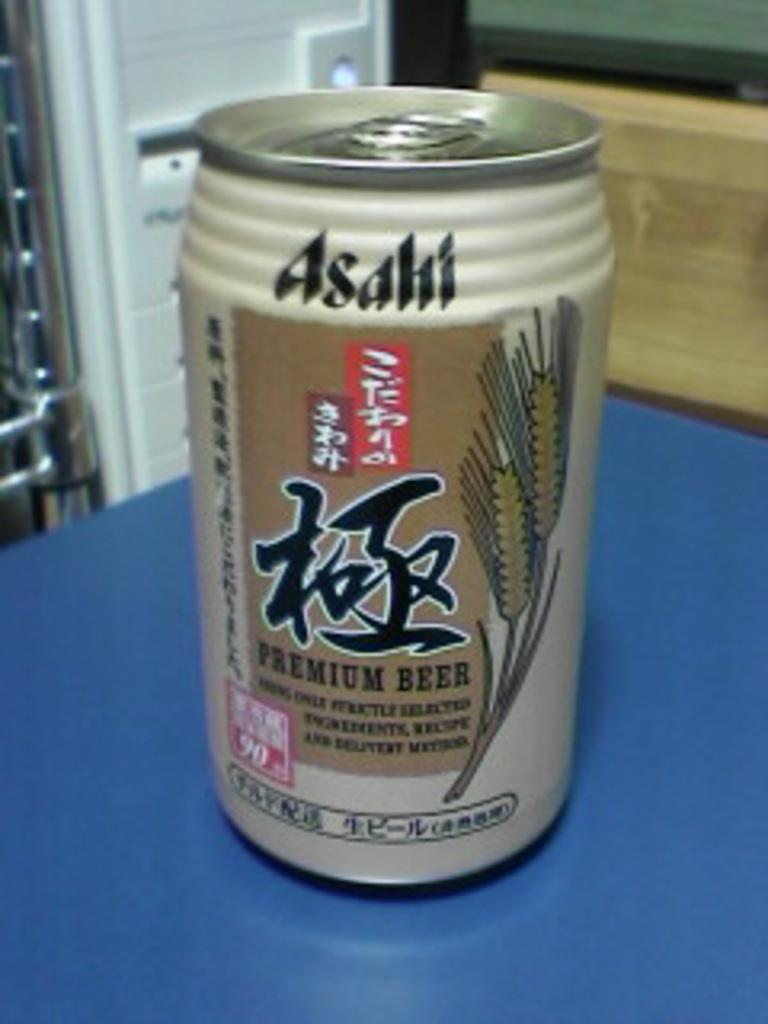<image>
Describe the image concisely. A can of Asahi Premium Beer sits on a table. 